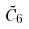Convert formula to latex. <formula><loc_0><loc_0><loc_500><loc_500>\tilde { C } _ { 6 }</formula> 